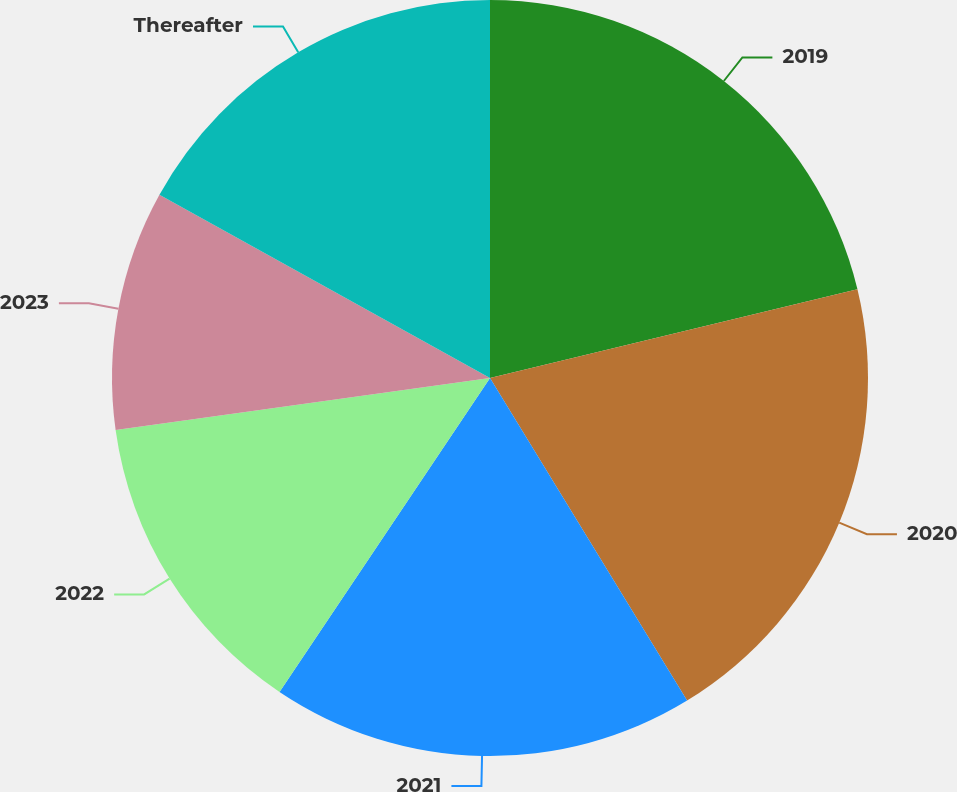Convert chart to OTSL. <chart><loc_0><loc_0><loc_500><loc_500><pie_chart><fcel>2019<fcel>2020<fcel>2021<fcel>2022<fcel>2023<fcel>Thereafter<nl><fcel>21.23%<fcel>20.04%<fcel>18.13%<fcel>13.4%<fcel>10.26%<fcel>16.94%<nl></chart> 